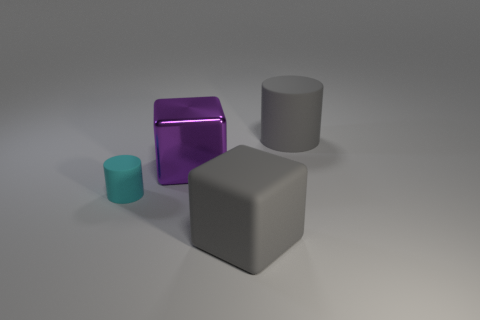What size is the cylinder left of the purple shiny cube?
Provide a short and direct response. Small. There is a metallic thing that is the same size as the matte block; what is its shape?
Offer a very short reply. Cube. Are the object left of the purple metallic block and the large cube to the left of the big gray rubber block made of the same material?
Make the answer very short. No. The cylinder left of the big gray object that is behind the large gray block is made of what material?
Provide a short and direct response. Rubber. What is the size of the rubber object that is to the right of the big gray thing to the left of the rubber cylinder to the right of the small cyan rubber object?
Offer a very short reply. Large. Does the cyan object have the same size as the gray cylinder?
Ensure brevity in your answer.  No. There is a large rubber object that is in front of the cyan object; does it have the same shape as the big gray rubber thing behind the tiny thing?
Offer a very short reply. No. Is there a big gray rubber block on the right side of the rubber object that is right of the big matte cube?
Provide a succinct answer. No. Are there any big brown rubber cylinders?
Make the answer very short. No. What number of gray matte cylinders have the same size as the gray rubber block?
Provide a succinct answer. 1. 